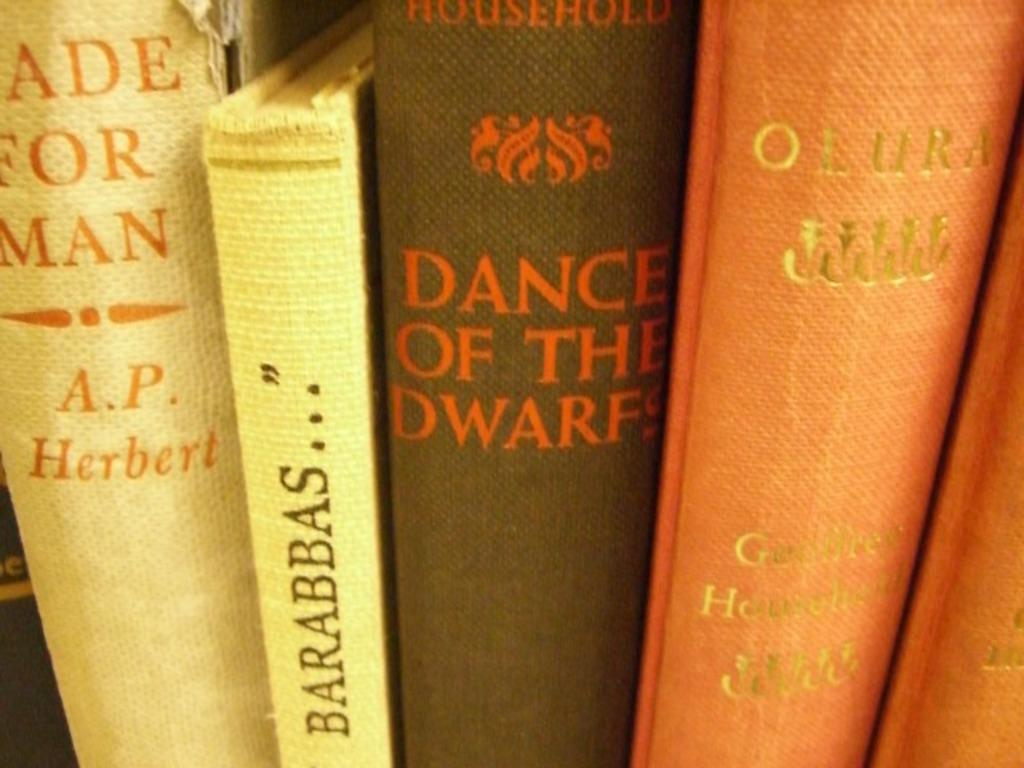<image>
Summarize the visual content of the image. Books are lined up together including one titled Dance of the Dwarfs. 